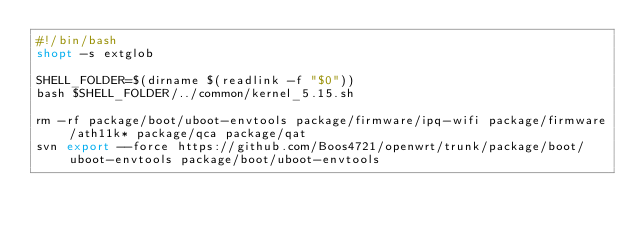Convert code to text. <code><loc_0><loc_0><loc_500><loc_500><_Bash_>#!/bin/bash
shopt -s extglob

SHELL_FOLDER=$(dirname $(readlink -f "$0"))
bash $SHELL_FOLDER/../common/kernel_5.15.sh

rm -rf package/boot/uboot-envtools package/firmware/ipq-wifi package/firmware/ath11k* package/qca package/qat
svn export --force https://github.com/Boos4721/openwrt/trunk/package/boot/uboot-envtools package/boot/uboot-envtools</code> 